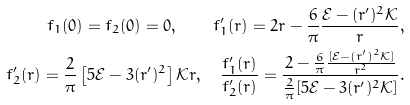<formula> <loc_0><loc_0><loc_500><loc_500>f _ { 1 } ( 0 ) = f _ { 2 } ( 0 ) = 0 , \quad f _ { 1 } ^ { \prime } ( r ) = 2 r - \frac { 6 } { \pi } \frac { \mathcal { E } - ( r ^ { \prime } ) ^ { 2 } \mathcal { K } } { r } , \\ f _ { 2 } ^ { \prime } ( r ) = \frac { 2 } { \pi } \left [ 5 \mathcal { E } - 3 ( r ^ { \prime } ) ^ { 2 } \right ] \mathcal { K } r , \quad \frac { f _ { 1 } ^ { \prime } ( r ) } { f _ { 2 } ^ { \prime } ( r ) } = \frac { 2 - \frac { 6 } { \pi } \frac { [ \mathcal { E } - ( r ^ { \prime } ) ^ { 2 } \mathcal { K } ] } { r ^ { 2 } } } { \frac { 2 } { \pi } [ 5 \mathcal { E } - 3 ( r ^ { \prime } ) ^ { 2 } \mathcal { K } ] } .</formula> 